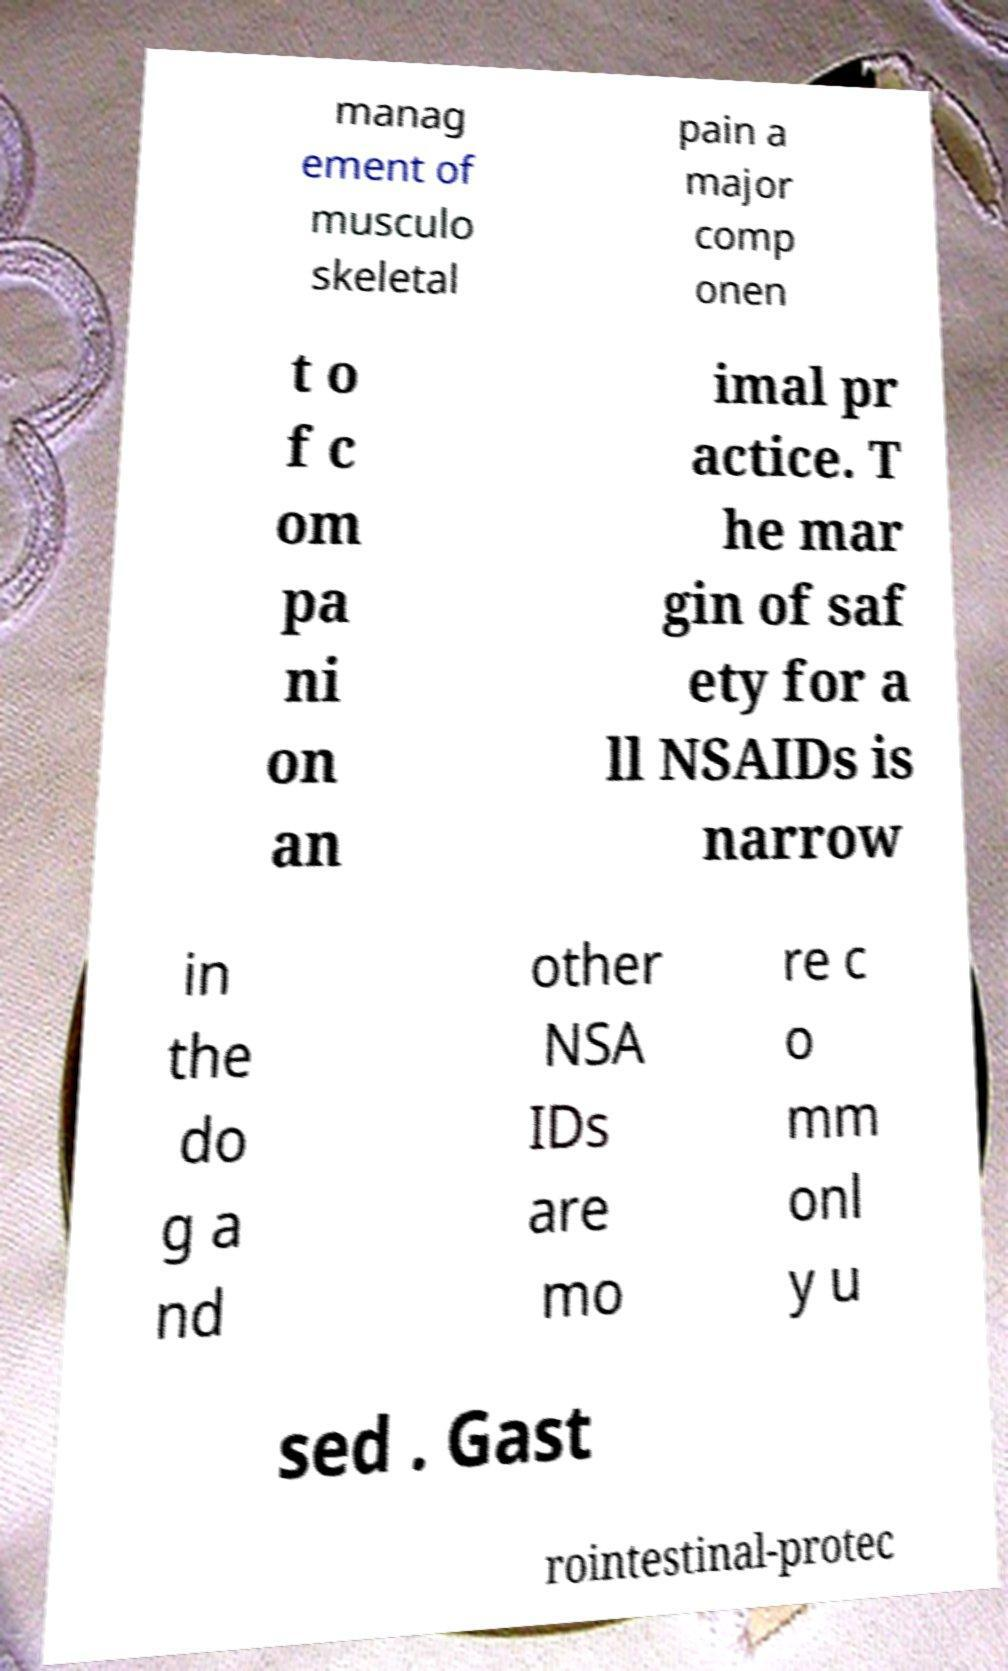What messages or text are displayed in this image? I need them in a readable, typed format. manag ement of musculo skeletal pain a major comp onen t o f c om pa ni on an imal pr actice. T he mar gin of saf ety for a ll NSAIDs is narrow in the do g a nd other NSA IDs are mo re c o mm onl y u sed . Gast rointestinal-protec 